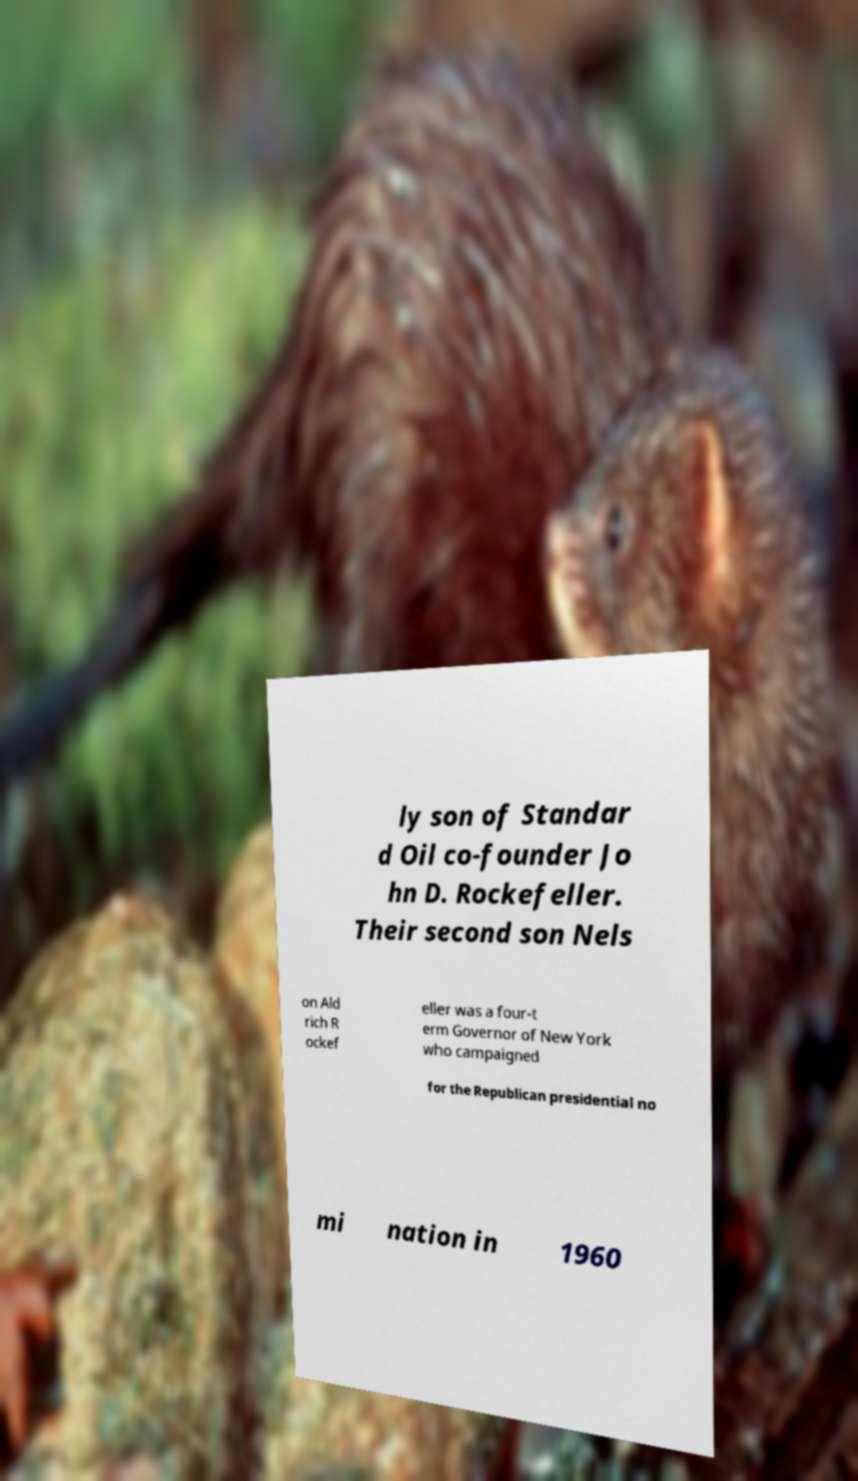Could you extract and type out the text from this image? ly son of Standar d Oil co-founder Jo hn D. Rockefeller. Their second son Nels on Ald rich R ockef eller was a four-t erm Governor of New York who campaigned for the Republican presidential no mi nation in 1960 